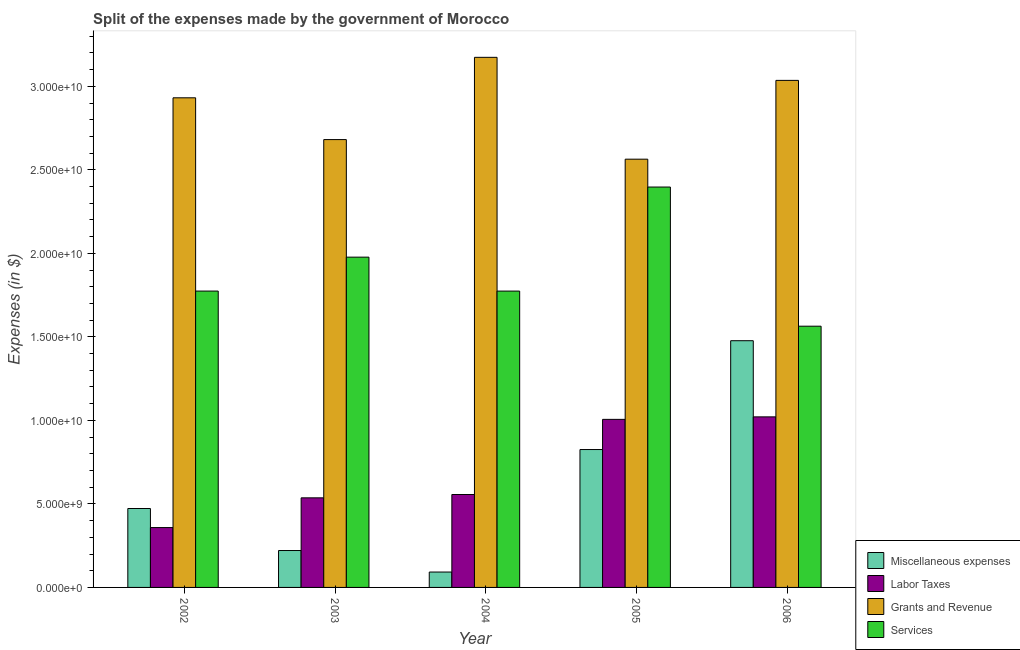How many groups of bars are there?
Provide a short and direct response. 5. Are the number of bars per tick equal to the number of legend labels?
Provide a short and direct response. Yes. How many bars are there on the 4th tick from the left?
Offer a very short reply. 4. What is the amount spent on services in 2006?
Make the answer very short. 1.56e+1. Across all years, what is the maximum amount spent on miscellaneous expenses?
Make the answer very short. 1.48e+1. Across all years, what is the minimum amount spent on labor taxes?
Keep it short and to the point. 3.58e+09. In which year was the amount spent on grants and revenue minimum?
Your answer should be compact. 2005. What is the total amount spent on grants and revenue in the graph?
Your response must be concise. 1.44e+11. What is the difference between the amount spent on services in 2002 and that in 2006?
Your answer should be very brief. 2.10e+09. What is the difference between the amount spent on miscellaneous expenses in 2005 and the amount spent on grants and revenue in 2002?
Provide a succinct answer. 3.53e+09. What is the average amount spent on miscellaneous expenses per year?
Make the answer very short. 6.18e+09. In the year 2004, what is the difference between the amount spent on services and amount spent on miscellaneous expenses?
Give a very brief answer. 0. In how many years, is the amount spent on grants and revenue greater than 9000000000 $?
Keep it short and to the point. 5. What is the ratio of the amount spent on labor taxes in 2003 to that in 2004?
Keep it short and to the point. 0.96. Is the difference between the amount spent on miscellaneous expenses in 2003 and 2006 greater than the difference between the amount spent on labor taxes in 2003 and 2006?
Make the answer very short. No. What is the difference between the highest and the second highest amount spent on services?
Give a very brief answer. 4.20e+09. What is the difference between the highest and the lowest amount spent on services?
Provide a succinct answer. 8.33e+09. In how many years, is the amount spent on miscellaneous expenses greater than the average amount spent on miscellaneous expenses taken over all years?
Your answer should be very brief. 2. Is the sum of the amount spent on grants and revenue in 2003 and 2006 greater than the maximum amount spent on miscellaneous expenses across all years?
Your answer should be very brief. Yes. What does the 1st bar from the left in 2003 represents?
Ensure brevity in your answer.  Miscellaneous expenses. What does the 3rd bar from the right in 2005 represents?
Ensure brevity in your answer.  Labor Taxes. Is it the case that in every year, the sum of the amount spent on miscellaneous expenses and amount spent on labor taxes is greater than the amount spent on grants and revenue?
Provide a succinct answer. No. How many bars are there?
Keep it short and to the point. 20. Does the graph contain any zero values?
Your answer should be very brief. No. Does the graph contain grids?
Make the answer very short. No. How are the legend labels stacked?
Provide a succinct answer. Vertical. What is the title of the graph?
Give a very brief answer. Split of the expenses made by the government of Morocco. Does "Social Awareness" appear as one of the legend labels in the graph?
Keep it short and to the point. No. What is the label or title of the X-axis?
Offer a terse response. Year. What is the label or title of the Y-axis?
Keep it short and to the point. Expenses (in $). What is the Expenses (in $) in Miscellaneous expenses in 2002?
Offer a terse response. 4.72e+09. What is the Expenses (in $) of Labor Taxes in 2002?
Provide a short and direct response. 3.58e+09. What is the Expenses (in $) of Grants and Revenue in 2002?
Your answer should be very brief. 2.93e+1. What is the Expenses (in $) in Services in 2002?
Your answer should be very brief. 1.77e+1. What is the Expenses (in $) of Miscellaneous expenses in 2003?
Keep it short and to the point. 2.21e+09. What is the Expenses (in $) in Labor Taxes in 2003?
Offer a terse response. 5.36e+09. What is the Expenses (in $) of Grants and Revenue in 2003?
Your answer should be very brief. 2.68e+1. What is the Expenses (in $) in Services in 2003?
Your answer should be very brief. 1.98e+1. What is the Expenses (in $) of Miscellaneous expenses in 2004?
Make the answer very short. 9.22e+08. What is the Expenses (in $) of Labor Taxes in 2004?
Offer a terse response. 5.56e+09. What is the Expenses (in $) in Grants and Revenue in 2004?
Make the answer very short. 3.17e+1. What is the Expenses (in $) in Services in 2004?
Provide a short and direct response. 1.77e+1. What is the Expenses (in $) of Miscellaneous expenses in 2005?
Provide a succinct answer. 8.26e+09. What is the Expenses (in $) in Labor Taxes in 2005?
Your answer should be compact. 1.01e+1. What is the Expenses (in $) in Grants and Revenue in 2005?
Your answer should be very brief. 2.56e+1. What is the Expenses (in $) in Services in 2005?
Make the answer very short. 2.40e+1. What is the Expenses (in $) of Miscellaneous expenses in 2006?
Offer a very short reply. 1.48e+1. What is the Expenses (in $) in Labor Taxes in 2006?
Provide a short and direct response. 1.02e+1. What is the Expenses (in $) of Grants and Revenue in 2006?
Give a very brief answer. 3.04e+1. What is the Expenses (in $) of Services in 2006?
Ensure brevity in your answer.  1.56e+1. Across all years, what is the maximum Expenses (in $) in Miscellaneous expenses?
Your answer should be compact. 1.48e+1. Across all years, what is the maximum Expenses (in $) of Labor Taxes?
Your response must be concise. 1.02e+1. Across all years, what is the maximum Expenses (in $) of Grants and Revenue?
Provide a short and direct response. 3.17e+1. Across all years, what is the maximum Expenses (in $) in Services?
Offer a very short reply. 2.40e+1. Across all years, what is the minimum Expenses (in $) in Miscellaneous expenses?
Provide a short and direct response. 9.22e+08. Across all years, what is the minimum Expenses (in $) of Labor Taxes?
Provide a succinct answer. 3.58e+09. Across all years, what is the minimum Expenses (in $) of Grants and Revenue?
Provide a succinct answer. 2.56e+1. Across all years, what is the minimum Expenses (in $) in Services?
Provide a succinct answer. 1.56e+1. What is the total Expenses (in $) in Miscellaneous expenses in the graph?
Ensure brevity in your answer.  3.09e+1. What is the total Expenses (in $) of Labor Taxes in the graph?
Provide a succinct answer. 3.48e+1. What is the total Expenses (in $) in Grants and Revenue in the graph?
Your answer should be compact. 1.44e+11. What is the total Expenses (in $) in Services in the graph?
Provide a short and direct response. 9.49e+1. What is the difference between the Expenses (in $) in Miscellaneous expenses in 2002 and that in 2003?
Keep it short and to the point. 2.52e+09. What is the difference between the Expenses (in $) in Labor Taxes in 2002 and that in 2003?
Your response must be concise. -1.78e+09. What is the difference between the Expenses (in $) of Grants and Revenue in 2002 and that in 2003?
Ensure brevity in your answer.  2.50e+09. What is the difference between the Expenses (in $) in Services in 2002 and that in 2003?
Ensure brevity in your answer.  -2.03e+09. What is the difference between the Expenses (in $) in Miscellaneous expenses in 2002 and that in 2004?
Give a very brief answer. 3.80e+09. What is the difference between the Expenses (in $) in Labor Taxes in 2002 and that in 2004?
Your answer should be very brief. -1.98e+09. What is the difference between the Expenses (in $) in Grants and Revenue in 2002 and that in 2004?
Offer a terse response. -2.42e+09. What is the difference between the Expenses (in $) in Services in 2002 and that in 2004?
Keep it short and to the point. 6.26e+05. What is the difference between the Expenses (in $) of Miscellaneous expenses in 2002 and that in 2005?
Your answer should be compact. -3.53e+09. What is the difference between the Expenses (in $) of Labor Taxes in 2002 and that in 2005?
Make the answer very short. -6.48e+09. What is the difference between the Expenses (in $) in Grants and Revenue in 2002 and that in 2005?
Your response must be concise. 3.67e+09. What is the difference between the Expenses (in $) of Services in 2002 and that in 2005?
Provide a succinct answer. -6.23e+09. What is the difference between the Expenses (in $) in Miscellaneous expenses in 2002 and that in 2006?
Ensure brevity in your answer.  -1.00e+1. What is the difference between the Expenses (in $) in Labor Taxes in 2002 and that in 2006?
Offer a very short reply. -6.63e+09. What is the difference between the Expenses (in $) in Grants and Revenue in 2002 and that in 2006?
Offer a very short reply. -1.04e+09. What is the difference between the Expenses (in $) in Services in 2002 and that in 2006?
Provide a short and direct response. 2.10e+09. What is the difference between the Expenses (in $) of Miscellaneous expenses in 2003 and that in 2004?
Make the answer very short. 1.29e+09. What is the difference between the Expenses (in $) of Labor Taxes in 2003 and that in 2004?
Your answer should be compact. -1.99e+08. What is the difference between the Expenses (in $) in Grants and Revenue in 2003 and that in 2004?
Your response must be concise. -4.92e+09. What is the difference between the Expenses (in $) of Services in 2003 and that in 2004?
Offer a very short reply. 2.03e+09. What is the difference between the Expenses (in $) in Miscellaneous expenses in 2003 and that in 2005?
Provide a succinct answer. -6.05e+09. What is the difference between the Expenses (in $) in Labor Taxes in 2003 and that in 2005?
Make the answer very short. -4.70e+09. What is the difference between the Expenses (in $) of Grants and Revenue in 2003 and that in 2005?
Keep it short and to the point. 1.17e+09. What is the difference between the Expenses (in $) in Services in 2003 and that in 2005?
Your response must be concise. -4.20e+09. What is the difference between the Expenses (in $) of Miscellaneous expenses in 2003 and that in 2006?
Give a very brief answer. -1.26e+1. What is the difference between the Expenses (in $) of Labor Taxes in 2003 and that in 2006?
Your answer should be compact. -4.85e+09. What is the difference between the Expenses (in $) in Grants and Revenue in 2003 and that in 2006?
Offer a terse response. -3.54e+09. What is the difference between the Expenses (in $) in Services in 2003 and that in 2006?
Your answer should be compact. 4.13e+09. What is the difference between the Expenses (in $) of Miscellaneous expenses in 2004 and that in 2005?
Make the answer very short. -7.33e+09. What is the difference between the Expenses (in $) of Labor Taxes in 2004 and that in 2005?
Your answer should be very brief. -4.50e+09. What is the difference between the Expenses (in $) of Grants and Revenue in 2004 and that in 2005?
Offer a terse response. 6.10e+09. What is the difference between the Expenses (in $) of Services in 2004 and that in 2005?
Offer a very short reply. -6.23e+09. What is the difference between the Expenses (in $) of Miscellaneous expenses in 2004 and that in 2006?
Your answer should be very brief. -1.38e+1. What is the difference between the Expenses (in $) in Labor Taxes in 2004 and that in 2006?
Your response must be concise. -4.65e+09. What is the difference between the Expenses (in $) in Grants and Revenue in 2004 and that in 2006?
Your response must be concise. 1.38e+09. What is the difference between the Expenses (in $) of Services in 2004 and that in 2006?
Your answer should be compact. 2.10e+09. What is the difference between the Expenses (in $) of Miscellaneous expenses in 2005 and that in 2006?
Provide a succinct answer. -6.52e+09. What is the difference between the Expenses (in $) in Labor Taxes in 2005 and that in 2006?
Your answer should be very brief. -1.49e+08. What is the difference between the Expenses (in $) in Grants and Revenue in 2005 and that in 2006?
Your response must be concise. -4.72e+09. What is the difference between the Expenses (in $) of Services in 2005 and that in 2006?
Keep it short and to the point. 8.33e+09. What is the difference between the Expenses (in $) in Miscellaneous expenses in 2002 and the Expenses (in $) in Labor Taxes in 2003?
Provide a succinct answer. -6.39e+08. What is the difference between the Expenses (in $) in Miscellaneous expenses in 2002 and the Expenses (in $) in Grants and Revenue in 2003?
Make the answer very short. -2.21e+1. What is the difference between the Expenses (in $) in Miscellaneous expenses in 2002 and the Expenses (in $) in Services in 2003?
Make the answer very short. -1.50e+1. What is the difference between the Expenses (in $) of Labor Taxes in 2002 and the Expenses (in $) of Grants and Revenue in 2003?
Your response must be concise. -2.32e+1. What is the difference between the Expenses (in $) of Labor Taxes in 2002 and the Expenses (in $) of Services in 2003?
Provide a short and direct response. -1.62e+1. What is the difference between the Expenses (in $) in Grants and Revenue in 2002 and the Expenses (in $) in Services in 2003?
Keep it short and to the point. 9.54e+09. What is the difference between the Expenses (in $) of Miscellaneous expenses in 2002 and the Expenses (in $) of Labor Taxes in 2004?
Your answer should be very brief. -8.38e+08. What is the difference between the Expenses (in $) in Miscellaneous expenses in 2002 and the Expenses (in $) in Grants and Revenue in 2004?
Your response must be concise. -2.70e+1. What is the difference between the Expenses (in $) of Miscellaneous expenses in 2002 and the Expenses (in $) of Services in 2004?
Your response must be concise. -1.30e+1. What is the difference between the Expenses (in $) in Labor Taxes in 2002 and the Expenses (in $) in Grants and Revenue in 2004?
Your response must be concise. -2.82e+1. What is the difference between the Expenses (in $) in Labor Taxes in 2002 and the Expenses (in $) in Services in 2004?
Ensure brevity in your answer.  -1.42e+1. What is the difference between the Expenses (in $) of Grants and Revenue in 2002 and the Expenses (in $) of Services in 2004?
Offer a very short reply. 1.16e+1. What is the difference between the Expenses (in $) in Miscellaneous expenses in 2002 and the Expenses (in $) in Labor Taxes in 2005?
Provide a succinct answer. -5.34e+09. What is the difference between the Expenses (in $) in Miscellaneous expenses in 2002 and the Expenses (in $) in Grants and Revenue in 2005?
Give a very brief answer. -2.09e+1. What is the difference between the Expenses (in $) in Miscellaneous expenses in 2002 and the Expenses (in $) in Services in 2005?
Your response must be concise. -1.92e+1. What is the difference between the Expenses (in $) in Labor Taxes in 2002 and the Expenses (in $) in Grants and Revenue in 2005?
Ensure brevity in your answer.  -2.21e+1. What is the difference between the Expenses (in $) in Labor Taxes in 2002 and the Expenses (in $) in Services in 2005?
Keep it short and to the point. -2.04e+1. What is the difference between the Expenses (in $) in Grants and Revenue in 2002 and the Expenses (in $) in Services in 2005?
Provide a short and direct response. 5.34e+09. What is the difference between the Expenses (in $) in Miscellaneous expenses in 2002 and the Expenses (in $) in Labor Taxes in 2006?
Offer a very short reply. -5.49e+09. What is the difference between the Expenses (in $) in Miscellaneous expenses in 2002 and the Expenses (in $) in Grants and Revenue in 2006?
Give a very brief answer. -2.56e+1. What is the difference between the Expenses (in $) of Miscellaneous expenses in 2002 and the Expenses (in $) of Services in 2006?
Your answer should be compact. -1.09e+1. What is the difference between the Expenses (in $) of Labor Taxes in 2002 and the Expenses (in $) of Grants and Revenue in 2006?
Your response must be concise. -2.68e+1. What is the difference between the Expenses (in $) of Labor Taxes in 2002 and the Expenses (in $) of Services in 2006?
Your answer should be compact. -1.21e+1. What is the difference between the Expenses (in $) of Grants and Revenue in 2002 and the Expenses (in $) of Services in 2006?
Offer a very short reply. 1.37e+1. What is the difference between the Expenses (in $) of Miscellaneous expenses in 2003 and the Expenses (in $) of Labor Taxes in 2004?
Ensure brevity in your answer.  -3.35e+09. What is the difference between the Expenses (in $) of Miscellaneous expenses in 2003 and the Expenses (in $) of Grants and Revenue in 2004?
Your answer should be very brief. -2.95e+1. What is the difference between the Expenses (in $) in Miscellaneous expenses in 2003 and the Expenses (in $) in Services in 2004?
Ensure brevity in your answer.  -1.55e+1. What is the difference between the Expenses (in $) in Labor Taxes in 2003 and the Expenses (in $) in Grants and Revenue in 2004?
Offer a terse response. -2.64e+1. What is the difference between the Expenses (in $) of Labor Taxes in 2003 and the Expenses (in $) of Services in 2004?
Offer a very short reply. -1.24e+1. What is the difference between the Expenses (in $) of Grants and Revenue in 2003 and the Expenses (in $) of Services in 2004?
Offer a very short reply. 9.07e+09. What is the difference between the Expenses (in $) of Miscellaneous expenses in 2003 and the Expenses (in $) of Labor Taxes in 2005?
Provide a succinct answer. -7.85e+09. What is the difference between the Expenses (in $) of Miscellaneous expenses in 2003 and the Expenses (in $) of Grants and Revenue in 2005?
Your answer should be very brief. -2.34e+1. What is the difference between the Expenses (in $) in Miscellaneous expenses in 2003 and the Expenses (in $) in Services in 2005?
Your answer should be very brief. -2.18e+1. What is the difference between the Expenses (in $) in Labor Taxes in 2003 and the Expenses (in $) in Grants and Revenue in 2005?
Offer a terse response. -2.03e+1. What is the difference between the Expenses (in $) in Labor Taxes in 2003 and the Expenses (in $) in Services in 2005?
Offer a very short reply. -1.86e+1. What is the difference between the Expenses (in $) of Grants and Revenue in 2003 and the Expenses (in $) of Services in 2005?
Give a very brief answer. 2.84e+09. What is the difference between the Expenses (in $) in Miscellaneous expenses in 2003 and the Expenses (in $) in Labor Taxes in 2006?
Your response must be concise. -8.00e+09. What is the difference between the Expenses (in $) of Miscellaneous expenses in 2003 and the Expenses (in $) of Grants and Revenue in 2006?
Provide a succinct answer. -2.81e+1. What is the difference between the Expenses (in $) of Miscellaneous expenses in 2003 and the Expenses (in $) of Services in 2006?
Make the answer very short. -1.34e+1. What is the difference between the Expenses (in $) in Labor Taxes in 2003 and the Expenses (in $) in Grants and Revenue in 2006?
Your response must be concise. -2.50e+1. What is the difference between the Expenses (in $) in Labor Taxes in 2003 and the Expenses (in $) in Services in 2006?
Provide a succinct answer. -1.03e+1. What is the difference between the Expenses (in $) of Grants and Revenue in 2003 and the Expenses (in $) of Services in 2006?
Your answer should be compact. 1.12e+1. What is the difference between the Expenses (in $) of Miscellaneous expenses in 2004 and the Expenses (in $) of Labor Taxes in 2005?
Provide a short and direct response. -9.14e+09. What is the difference between the Expenses (in $) of Miscellaneous expenses in 2004 and the Expenses (in $) of Grants and Revenue in 2005?
Make the answer very short. -2.47e+1. What is the difference between the Expenses (in $) in Miscellaneous expenses in 2004 and the Expenses (in $) in Services in 2005?
Make the answer very short. -2.30e+1. What is the difference between the Expenses (in $) of Labor Taxes in 2004 and the Expenses (in $) of Grants and Revenue in 2005?
Your answer should be very brief. -2.01e+1. What is the difference between the Expenses (in $) in Labor Taxes in 2004 and the Expenses (in $) in Services in 2005?
Ensure brevity in your answer.  -1.84e+1. What is the difference between the Expenses (in $) in Grants and Revenue in 2004 and the Expenses (in $) in Services in 2005?
Keep it short and to the point. 7.77e+09. What is the difference between the Expenses (in $) of Miscellaneous expenses in 2004 and the Expenses (in $) of Labor Taxes in 2006?
Offer a terse response. -9.29e+09. What is the difference between the Expenses (in $) of Miscellaneous expenses in 2004 and the Expenses (in $) of Grants and Revenue in 2006?
Provide a short and direct response. -2.94e+1. What is the difference between the Expenses (in $) of Miscellaneous expenses in 2004 and the Expenses (in $) of Services in 2006?
Give a very brief answer. -1.47e+1. What is the difference between the Expenses (in $) of Labor Taxes in 2004 and the Expenses (in $) of Grants and Revenue in 2006?
Your response must be concise. -2.48e+1. What is the difference between the Expenses (in $) in Labor Taxes in 2004 and the Expenses (in $) in Services in 2006?
Offer a terse response. -1.01e+1. What is the difference between the Expenses (in $) in Grants and Revenue in 2004 and the Expenses (in $) in Services in 2006?
Make the answer very short. 1.61e+1. What is the difference between the Expenses (in $) in Miscellaneous expenses in 2005 and the Expenses (in $) in Labor Taxes in 2006?
Offer a very short reply. -1.96e+09. What is the difference between the Expenses (in $) in Miscellaneous expenses in 2005 and the Expenses (in $) in Grants and Revenue in 2006?
Ensure brevity in your answer.  -2.21e+1. What is the difference between the Expenses (in $) in Miscellaneous expenses in 2005 and the Expenses (in $) in Services in 2006?
Provide a succinct answer. -7.38e+09. What is the difference between the Expenses (in $) of Labor Taxes in 2005 and the Expenses (in $) of Grants and Revenue in 2006?
Your answer should be very brief. -2.03e+1. What is the difference between the Expenses (in $) of Labor Taxes in 2005 and the Expenses (in $) of Services in 2006?
Your answer should be compact. -5.58e+09. What is the difference between the Expenses (in $) in Grants and Revenue in 2005 and the Expenses (in $) in Services in 2006?
Your answer should be compact. 1.00e+1. What is the average Expenses (in $) in Miscellaneous expenses per year?
Ensure brevity in your answer.  6.18e+09. What is the average Expenses (in $) of Labor Taxes per year?
Offer a terse response. 6.96e+09. What is the average Expenses (in $) in Grants and Revenue per year?
Your answer should be compact. 2.88e+1. What is the average Expenses (in $) in Services per year?
Give a very brief answer. 1.90e+1. In the year 2002, what is the difference between the Expenses (in $) of Miscellaneous expenses and Expenses (in $) of Labor Taxes?
Your answer should be very brief. 1.14e+09. In the year 2002, what is the difference between the Expenses (in $) of Miscellaneous expenses and Expenses (in $) of Grants and Revenue?
Offer a terse response. -2.46e+1. In the year 2002, what is the difference between the Expenses (in $) of Miscellaneous expenses and Expenses (in $) of Services?
Offer a very short reply. -1.30e+1. In the year 2002, what is the difference between the Expenses (in $) of Labor Taxes and Expenses (in $) of Grants and Revenue?
Provide a short and direct response. -2.57e+1. In the year 2002, what is the difference between the Expenses (in $) of Labor Taxes and Expenses (in $) of Services?
Keep it short and to the point. -1.42e+1. In the year 2002, what is the difference between the Expenses (in $) in Grants and Revenue and Expenses (in $) in Services?
Keep it short and to the point. 1.16e+1. In the year 2003, what is the difference between the Expenses (in $) in Miscellaneous expenses and Expenses (in $) in Labor Taxes?
Your response must be concise. -3.16e+09. In the year 2003, what is the difference between the Expenses (in $) of Miscellaneous expenses and Expenses (in $) of Grants and Revenue?
Offer a very short reply. -2.46e+1. In the year 2003, what is the difference between the Expenses (in $) of Miscellaneous expenses and Expenses (in $) of Services?
Give a very brief answer. -1.76e+1. In the year 2003, what is the difference between the Expenses (in $) of Labor Taxes and Expenses (in $) of Grants and Revenue?
Keep it short and to the point. -2.14e+1. In the year 2003, what is the difference between the Expenses (in $) of Labor Taxes and Expenses (in $) of Services?
Your response must be concise. -1.44e+1. In the year 2003, what is the difference between the Expenses (in $) in Grants and Revenue and Expenses (in $) in Services?
Your response must be concise. 7.04e+09. In the year 2004, what is the difference between the Expenses (in $) in Miscellaneous expenses and Expenses (in $) in Labor Taxes?
Keep it short and to the point. -4.64e+09. In the year 2004, what is the difference between the Expenses (in $) of Miscellaneous expenses and Expenses (in $) of Grants and Revenue?
Your answer should be compact. -3.08e+1. In the year 2004, what is the difference between the Expenses (in $) in Miscellaneous expenses and Expenses (in $) in Services?
Provide a succinct answer. -1.68e+1. In the year 2004, what is the difference between the Expenses (in $) in Labor Taxes and Expenses (in $) in Grants and Revenue?
Give a very brief answer. -2.62e+1. In the year 2004, what is the difference between the Expenses (in $) in Labor Taxes and Expenses (in $) in Services?
Your response must be concise. -1.22e+1. In the year 2004, what is the difference between the Expenses (in $) of Grants and Revenue and Expenses (in $) of Services?
Ensure brevity in your answer.  1.40e+1. In the year 2005, what is the difference between the Expenses (in $) of Miscellaneous expenses and Expenses (in $) of Labor Taxes?
Your response must be concise. -1.81e+09. In the year 2005, what is the difference between the Expenses (in $) of Miscellaneous expenses and Expenses (in $) of Grants and Revenue?
Your answer should be compact. -1.74e+1. In the year 2005, what is the difference between the Expenses (in $) of Miscellaneous expenses and Expenses (in $) of Services?
Offer a very short reply. -1.57e+1. In the year 2005, what is the difference between the Expenses (in $) in Labor Taxes and Expenses (in $) in Grants and Revenue?
Provide a short and direct response. -1.56e+1. In the year 2005, what is the difference between the Expenses (in $) in Labor Taxes and Expenses (in $) in Services?
Your answer should be very brief. -1.39e+1. In the year 2005, what is the difference between the Expenses (in $) in Grants and Revenue and Expenses (in $) in Services?
Give a very brief answer. 1.67e+09. In the year 2006, what is the difference between the Expenses (in $) of Miscellaneous expenses and Expenses (in $) of Labor Taxes?
Your answer should be very brief. 4.56e+09. In the year 2006, what is the difference between the Expenses (in $) of Miscellaneous expenses and Expenses (in $) of Grants and Revenue?
Make the answer very short. -1.56e+1. In the year 2006, what is the difference between the Expenses (in $) in Miscellaneous expenses and Expenses (in $) in Services?
Your response must be concise. -8.69e+08. In the year 2006, what is the difference between the Expenses (in $) in Labor Taxes and Expenses (in $) in Grants and Revenue?
Ensure brevity in your answer.  -2.01e+1. In the year 2006, what is the difference between the Expenses (in $) in Labor Taxes and Expenses (in $) in Services?
Your answer should be compact. -5.43e+09. In the year 2006, what is the difference between the Expenses (in $) of Grants and Revenue and Expenses (in $) of Services?
Give a very brief answer. 1.47e+1. What is the ratio of the Expenses (in $) of Miscellaneous expenses in 2002 to that in 2003?
Your answer should be compact. 2.14. What is the ratio of the Expenses (in $) in Labor Taxes in 2002 to that in 2003?
Offer a very short reply. 0.67. What is the ratio of the Expenses (in $) of Grants and Revenue in 2002 to that in 2003?
Make the answer very short. 1.09. What is the ratio of the Expenses (in $) in Services in 2002 to that in 2003?
Your answer should be very brief. 0.9. What is the ratio of the Expenses (in $) of Miscellaneous expenses in 2002 to that in 2004?
Provide a short and direct response. 5.13. What is the ratio of the Expenses (in $) of Labor Taxes in 2002 to that in 2004?
Provide a short and direct response. 0.64. What is the ratio of the Expenses (in $) of Grants and Revenue in 2002 to that in 2004?
Ensure brevity in your answer.  0.92. What is the ratio of the Expenses (in $) of Services in 2002 to that in 2004?
Your response must be concise. 1. What is the ratio of the Expenses (in $) in Miscellaneous expenses in 2002 to that in 2005?
Ensure brevity in your answer.  0.57. What is the ratio of the Expenses (in $) of Labor Taxes in 2002 to that in 2005?
Give a very brief answer. 0.36. What is the ratio of the Expenses (in $) of Grants and Revenue in 2002 to that in 2005?
Offer a very short reply. 1.14. What is the ratio of the Expenses (in $) in Services in 2002 to that in 2005?
Your response must be concise. 0.74. What is the ratio of the Expenses (in $) in Miscellaneous expenses in 2002 to that in 2006?
Offer a very short reply. 0.32. What is the ratio of the Expenses (in $) in Labor Taxes in 2002 to that in 2006?
Your answer should be very brief. 0.35. What is the ratio of the Expenses (in $) of Grants and Revenue in 2002 to that in 2006?
Offer a very short reply. 0.97. What is the ratio of the Expenses (in $) of Services in 2002 to that in 2006?
Ensure brevity in your answer.  1.13. What is the ratio of the Expenses (in $) in Miscellaneous expenses in 2003 to that in 2004?
Offer a very short reply. 2.4. What is the ratio of the Expenses (in $) of Labor Taxes in 2003 to that in 2004?
Your answer should be compact. 0.96. What is the ratio of the Expenses (in $) of Grants and Revenue in 2003 to that in 2004?
Provide a short and direct response. 0.84. What is the ratio of the Expenses (in $) of Services in 2003 to that in 2004?
Your answer should be compact. 1.11. What is the ratio of the Expenses (in $) of Miscellaneous expenses in 2003 to that in 2005?
Your answer should be compact. 0.27. What is the ratio of the Expenses (in $) of Labor Taxes in 2003 to that in 2005?
Your response must be concise. 0.53. What is the ratio of the Expenses (in $) in Grants and Revenue in 2003 to that in 2005?
Offer a very short reply. 1.05. What is the ratio of the Expenses (in $) in Services in 2003 to that in 2005?
Ensure brevity in your answer.  0.82. What is the ratio of the Expenses (in $) of Miscellaneous expenses in 2003 to that in 2006?
Your response must be concise. 0.15. What is the ratio of the Expenses (in $) in Labor Taxes in 2003 to that in 2006?
Offer a very short reply. 0.53. What is the ratio of the Expenses (in $) of Grants and Revenue in 2003 to that in 2006?
Offer a terse response. 0.88. What is the ratio of the Expenses (in $) of Services in 2003 to that in 2006?
Keep it short and to the point. 1.26. What is the ratio of the Expenses (in $) of Miscellaneous expenses in 2004 to that in 2005?
Make the answer very short. 0.11. What is the ratio of the Expenses (in $) in Labor Taxes in 2004 to that in 2005?
Offer a terse response. 0.55. What is the ratio of the Expenses (in $) in Grants and Revenue in 2004 to that in 2005?
Ensure brevity in your answer.  1.24. What is the ratio of the Expenses (in $) in Services in 2004 to that in 2005?
Ensure brevity in your answer.  0.74. What is the ratio of the Expenses (in $) in Miscellaneous expenses in 2004 to that in 2006?
Make the answer very short. 0.06. What is the ratio of the Expenses (in $) of Labor Taxes in 2004 to that in 2006?
Offer a very short reply. 0.54. What is the ratio of the Expenses (in $) of Grants and Revenue in 2004 to that in 2006?
Ensure brevity in your answer.  1.05. What is the ratio of the Expenses (in $) of Services in 2004 to that in 2006?
Ensure brevity in your answer.  1.13. What is the ratio of the Expenses (in $) in Miscellaneous expenses in 2005 to that in 2006?
Your answer should be compact. 0.56. What is the ratio of the Expenses (in $) in Labor Taxes in 2005 to that in 2006?
Give a very brief answer. 0.99. What is the ratio of the Expenses (in $) of Grants and Revenue in 2005 to that in 2006?
Offer a terse response. 0.84. What is the ratio of the Expenses (in $) in Services in 2005 to that in 2006?
Make the answer very short. 1.53. What is the difference between the highest and the second highest Expenses (in $) in Miscellaneous expenses?
Give a very brief answer. 6.52e+09. What is the difference between the highest and the second highest Expenses (in $) in Labor Taxes?
Keep it short and to the point. 1.49e+08. What is the difference between the highest and the second highest Expenses (in $) of Grants and Revenue?
Provide a short and direct response. 1.38e+09. What is the difference between the highest and the second highest Expenses (in $) of Services?
Make the answer very short. 4.20e+09. What is the difference between the highest and the lowest Expenses (in $) of Miscellaneous expenses?
Offer a terse response. 1.38e+1. What is the difference between the highest and the lowest Expenses (in $) of Labor Taxes?
Keep it short and to the point. 6.63e+09. What is the difference between the highest and the lowest Expenses (in $) in Grants and Revenue?
Give a very brief answer. 6.10e+09. What is the difference between the highest and the lowest Expenses (in $) in Services?
Offer a very short reply. 8.33e+09. 